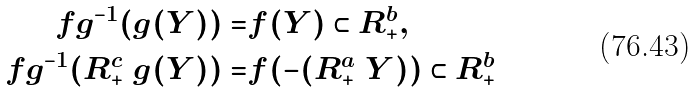<formula> <loc_0><loc_0><loc_500><loc_500>f g ^ { - 1 } ( g ( Y ) ) = & f ( Y ) \subset R _ { + } ^ { b } , \\ f g ^ { - 1 } ( R _ { + } ^ { c } \ g ( Y ) ) = & f ( - ( R _ { + } ^ { a } \ Y ) ) \subset R _ { + } ^ { b }</formula> 